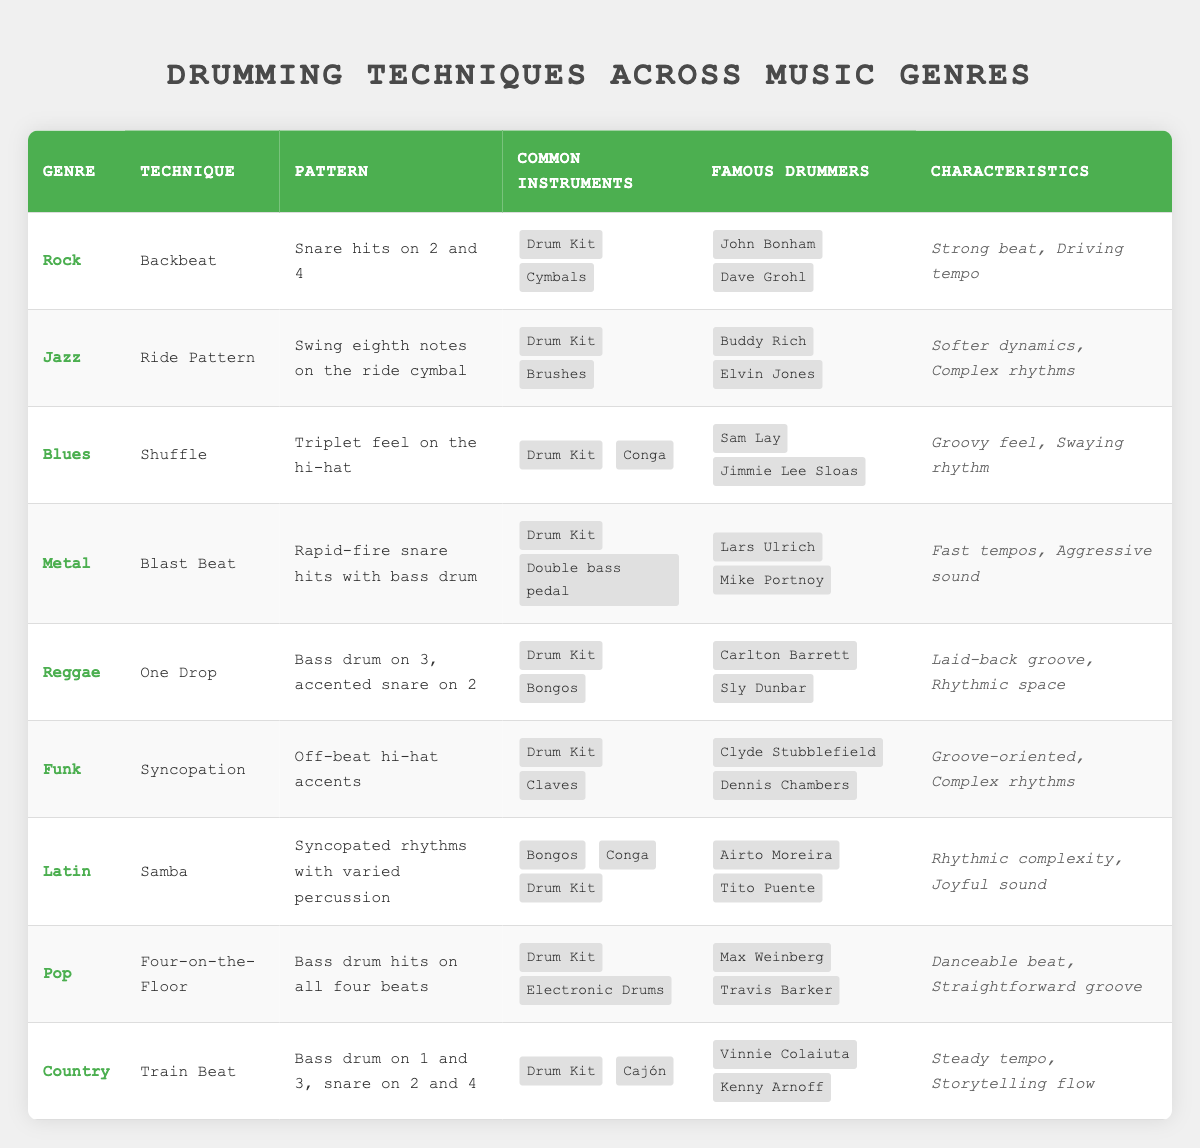What drumming technique is commonly used in Rock music? The table shows that the technique associated with Rock music is the Backbeat.
Answer: Backbeat Who are two famous drummers from the Jazz genre? The Jazz section lists Buddy Rich and Elvin Jones as famous drummers.
Answer: Buddy Rich, Elvin Jones Does the Samba technique involve using a Drum Kit? By checking the Latin genre, we can see Samba includes a Drum Kit among its common instruments.
Answer: Yes Which genre has the characteristic of a laid-back groove? Looking at the Reggae section, it states that one of its characteristics is a laid-back groove.
Answer: Reggae In how many genres is a Drum Kit listed as a common instrument? Counting the occurrences in the table, a Drum Kit appears in Rock, Jazz, Blues, Metal, Reggae, Funk, Latin, Pop, and Country, totaling 9 genres.
Answer: 9 Which technique is associated with complex rhythms in the Funk genre? The table indicates that the technique used in Funk is Syncopation, which is described as having complex rhythms.
Answer: Syncopation Is there a technique in Blues that features a triplet feel? The Blues technique mentioned is Shuffle, which specifically describes a triplet feel on the hi-hat.
Answer: Yes What is the pattern for the One Drop technique in Reggae? The pattern is specified in the table as the bass drum on 3 and an accented snare on 2.
Answer: Bass drum on 3, accented snare on 2 Which genre's drumming technique involves rapid-fire snare hits? The technique known as Blast Beat, related to Metal music, involves rapid-fire snare hits.
Answer: Metal 